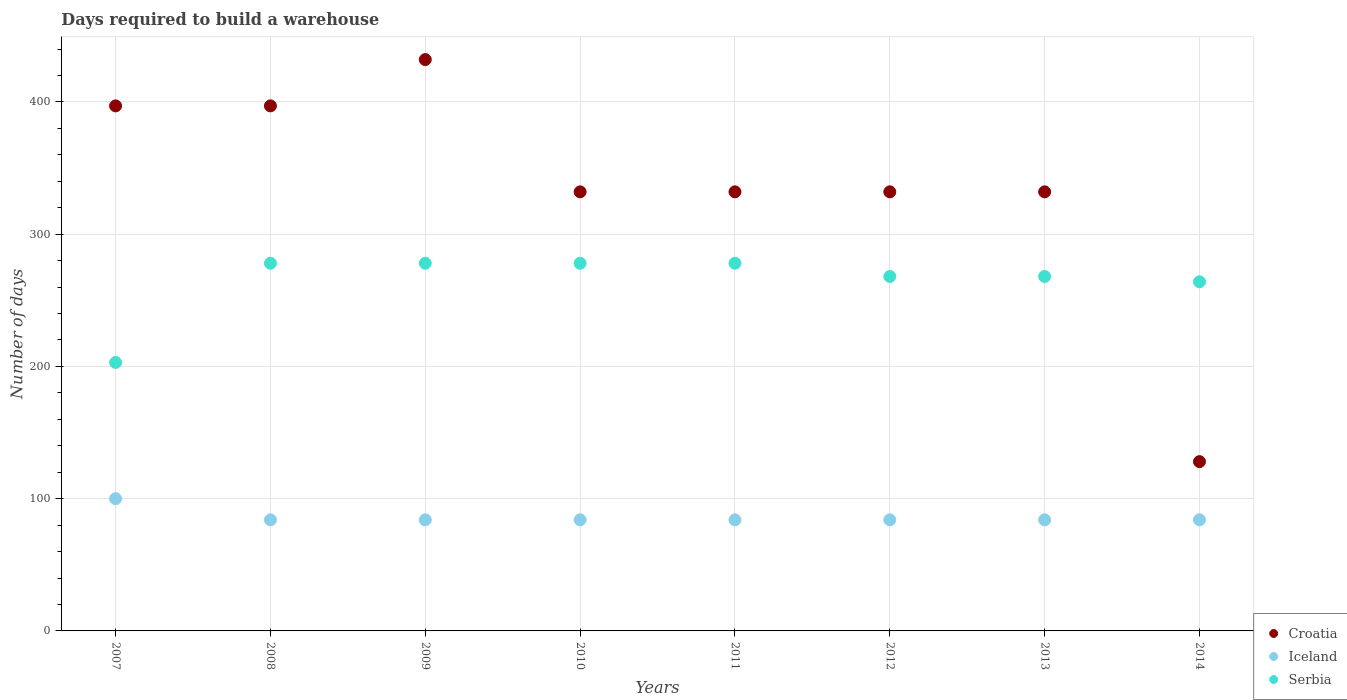What is the days required to build a warehouse in in Iceland in 2009?
Offer a very short reply. 84. Across all years, what is the maximum days required to build a warehouse in in Croatia?
Ensure brevity in your answer.  432. Across all years, what is the minimum days required to build a warehouse in in Croatia?
Ensure brevity in your answer.  128. In which year was the days required to build a warehouse in in Serbia maximum?
Your answer should be very brief. 2008. What is the total days required to build a warehouse in in Serbia in the graph?
Provide a short and direct response. 2115. What is the difference between the days required to build a warehouse in in Serbia in 2007 and that in 2014?
Keep it short and to the point. -61. What is the difference between the days required to build a warehouse in in Serbia in 2014 and the days required to build a warehouse in in Croatia in 2010?
Your answer should be compact. -68. What is the average days required to build a warehouse in in Iceland per year?
Ensure brevity in your answer.  86. In the year 2010, what is the difference between the days required to build a warehouse in in Croatia and days required to build a warehouse in in Iceland?
Provide a short and direct response. 248. In how many years, is the days required to build a warehouse in in Serbia greater than 420 days?
Provide a succinct answer. 0. What is the ratio of the days required to build a warehouse in in Croatia in 2011 to that in 2013?
Provide a succinct answer. 1. Is the days required to build a warehouse in in Croatia in 2011 less than that in 2012?
Your answer should be compact. No. What is the difference between the highest and the second highest days required to build a warehouse in in Croatia?
Your response must be concise. 35. What is the difference between the highest and the lowest days required to build a warehouse in in Iceland?
Give a very brief answer. 16. Is the sum of the days required to build a warehouse in in Serbia in 2007 and 2009 greater than the maximum days required to build a warehouse in in Croatia across all years?
Ensure brevity in your answer.  Yes. Does the days required to build a warehouse in in Iceland monotonically increase over the years?
Offer a very short reply. No. How many dotlines are there?
Offer a terse response. 3. How many years are there in the graph?
Provide a succinct answer. 8. Are the values on the major ticks of Y-axis written in scientific E-notation?
Offer a terse response. No. Does the graph contain grids?
Ensure brevity in your answer.  Yes. Where does the legend appear in the graph?
Make the answer very short. Bottom right. How are the legend labels stacked?
Make the answer very short. Vertical. What is the title of the graph?
Your answer should be compact. Days required to build a warehouse. What is the label or title of the X-axis?
Provide a short and direct response. Years. What is the label or title of the Y-axis?
Keep it short and to the point. Number of days. What is the Number of days in Croatia in 2007?
Offer a very short reply. 397. What is the Number of days of Iceland in 2007?
Your answer should be compact. 100. What is the Number of days in Serbia in 2007?
Keep it short and to the point. 203. What is the Number of days of Croatia in 2008?
Provide a succinct answer. 397. What is the Number of days in Iceland in 2008?
Offer a terse response. 84. What is the Number of days of Serbia in 2008?
Your answer should be compact. 278. What is the Number of days of Croatia in 2009?
Offer a terse response. 432. What is the Number of days in Serbia in 2009?
Offer a very short reply. 278. What is the Number of days in Croatia in 2010?
Offer a terse response. 332. What is the Number of days of Serbia in 2010?
Make the answer very short. 278. What is the Number of days in Croatia in 2011?
Provide a short and direct response. 332. What is the Number of days of Iceland in 2011?
Your answer should be very brief. 84. What is the Number of days in Serbia in 2011?
Your response must be concise. 278. What is the Number of days in Croatia in 2012?
Your answer should be compact. 332. What is the Number of days of Serbia in 2012?
Keep it short and to the point. 268. What is the Number of days of Croatia in 2013?
Offer a very short reply. 332. What is the Number of days of Serbia in 2013?
Give a very brief answer. 268. What is the Number of days of Croatia in 2014?
Ensure brevity in your answer.  128. What is the Number of days in Iceland in 2014?
Keep it short and to the point. 84. What is the Number of days in Serbia in 2014?
Your answer should be very brief. 264. Across all years, what is the maximum Number of days of Croatia?
Your answer should be compact. 432. Across all years, what is the maximum Number of days of Serbia?
Your answer should be very brief. 278. Across all years, what is the minimum Number of days of Croatia?
Your response must be concise. 128. Across all years, what is the minimum Number of days of Iceland?
Provide a succinct answer. 84. Across all years, what is the minimum Number of days of Serbia?
Make the answer very short. 203. What is the total Number of days in Croatia in the graph?
Your response must be concise. 2682. What is the total Number of days in Iceland in the graph?
Give a very brief answer. 688. What is the total Number of days of Serbia in the graph?
Offer a very short reply. 2115. What is the difference between the Number of days of Croatia in 2007 and that in 2008?
Your answer should be compact. 0. What is the difference between the Number of days in Iceland in 2007 and that in 2008?
Your answer should be compact. 16. What is the difference between the Number of days in Serbia in 2007 and that in 2008?
Ensure brevity in your answer.  -75. What is the difference between the Number of days in Croatia in 2007 and that in 2009?
Keep it short and to the point. -35. What is the difference between the Number of days of Serbia in 2007 and that in 2009?
Give a very brief answer. -75. What is the difference between the Number of days in Croatia in 2007 and that in 2010?
Your answer should be compact. 65. What is the difference between the Number of days of Serbia in 2007 and that in 2010?
Offer a very short reply. -75. What is the difference between the Number of days in Serbia in 2007 and that in 2011?
Your answer should be compact. -75. What is the difference between the Number of days of Croatia in 2007 and that in 2012?
Give a very brief answer. 65. What is the difference between the Number of days of Iceland in 2007 and that in 2012?
Your answer should be very brief. 16. What is the difference between the Number of days of Serbia in 2007 and that in 2012?
Make the answer very short. -65. What is the difference between the Number of days of Croatia in 2007 and that in 2013?
Keep it short and to the point. 65. What is the difference between the Number of days in Iceland in 2007 and that in 2013?
Your answer should be very brief. 16. What is the difference between the Number of days in Serbia in 2007 and that in 2013?
Make the answer very short. -65. What is the difference between the Number of days of Croatia in 2007 and that in 2014?
Offer a terse response. 269. What is the difference between the Number of days in Iceland in 2007 and that in 2014?
Ensure brevity in your answer.  16. What is the difference between the Number of days in Serbia in 2007 and that in 2014?
Your answer should be compact. -61. What is the difference between the Number of days of Croatia in 2008 and that in 2009?
Your response must be concise. -35. What is the difference between the Number of days of Iceland in 2008 and that in 2009?
Your answer should be compact. 0. What is the difference between the Number of days of Serbia in 2008 and that in 2009?
Ensure brevity in your answer.  0. What is the difference between the Number of days of Iceland in 2008 and that in 2010?
Keep it short and to the point. 0. What is the difference between the Number of days in Croatia in 2008 and that in 2011?
Your answer should be compact. 65. What is the difference between the Number of days in Iceland in 2008 and that in 2011?
Your answer should be very brief. 0. What is the difference between the Number of days in Croatia in 2008 and that in 2012?
Make the answer very short. 65. What is the difference between the Number of days of Iceland in 2008 and that in 2012?
Your answer should be very brief. 0. What is the difference between the Number of days of Serbia in 2008 and that in 2012?
Provide a short and direct response. 10. What is the difference between the Number of days in Croatia in 2008 and that in 2013?
Offer a very short reply. 65. What is the difference between the Number of days in Iceland in 2008 and that in 2013?
Your response must be concise. 0. What is the difference between the Number of days of Croatia in 2008 and that in 2014?
Your response must be concise. 269. What is the difference between the Number of days in Iceland in 2008 and that in 2014?
Ensure brevity in your answer.  0. What is the difference between the Number of days in Serbia in 2008 and that in 2014?
Your answer should be very brief. 14. What is the difference between the Number of days in Croatia in 2009 and that in 2010?
Provide a succinct answer. 100. What is the difference between the Number of days of Serbia in 2009 and that in 2010?
Offer a very short reply. 0. What is the difference between the Number of days in Serbia in 2009 and that in 2011?
Your answer should be compact. 0. What is the difference between the Number of days in Serbia in 2009 and that in 2012?
Your response must be concise. 10. What is the difference between the Number of days in Croatia in 2009 and that in 2013?
Provide a succinct answer. 100. What is the difference between the Number of days in Iceland in 2009 and that in 2013?
Make the answer very short. 0. What is the difference between the Number of days in Croatia in 2009 and that in 2014?
Make the answer very short. 304. What is the difference between the Number of days in Iceland in 2009 and that in 2014?
Offer a very short reply. 0. What is the difference between the Number of days in Croatia in 2010 and that in 2011?
Keep it short and to the point. 0. What is the difference between the Number of days in Iceland in 2010 and that in 2011?
Your response must be concise. 0. What is the difference between the Number of days in Serbia in 2010 and that in 2011?
Make the answer very short. 0. What is the difference between the Number of days of Croatia in 2010 and that in 2013?
Your answer should be compact. 0. What is the difference between the Number of days of Croatia in 2010 and that in 2014?
Give a very brief answer. 204. What is the difference between the Number of days of Croatia in 2011 and that in 2012?
Provide a short and direct response. 0. What is the difference between the Number of days of Iceland in 2011 and that in 2012?
Provide a succinct answer. 0. What is the difference between the Number of days in Serbia in 2011 and that in 2012?
Provide a succinct answer. 10. What is the difference between the Number of days of Croatia in 2011 and that in 2013?
Give a very brief answer. 0. What is the difference between the Number of days of Iceland in 2011 and that in 2013?
Offer a very short reply. 0. What is the difference between the Number of days of Croatia in 2011 and that in 2014?
Ensure brevity in your answer.  204. What is the difference between the Number of days of Croatia in 2012 and that in 2013?
Keep it short and to the point. 0. What is the difference between the Number of days of Iceland in 2012 and that in 2013?
Offer a very short reply. 0. What is the difference between the Number of days of Serbia in 2012 and that in 2013?
Your answer should be compact. 0. What is the difference between the Number of days of Croatia in 2012 and that in 2014?
Your answer should be very brief. 204. What is the difference between the Number of days in Iceland in 2012 and that in 2014?
Provide a short and direct response. 0. What is the difference between the Number of days in Serbia in 2012 and that in 2014?
Make the answer very short. 4. What is the difference between the Number of days of Croatia in 2013 and that in 2014?
Provide a short and direct response. 204. What is the difference between the Number of days in Iceland in 2013 and that in 2014?
Make the answer very short. 0. What is the difference between the Number of days in Serbia in 2013 and that in 2014?
Your response must be concise. 4. What is the difference between the Number of days in Croatia in 2007 and the Number of days in Iceland in 2008?
Make the answer very short. 313. What is the difference between the Number of days of Croatia in 2007 and the Number of days of Serbia in 2008?
Ensure brevity in your answer.  119. What is the difference between the Number of days of Iceland in 2007 and the Number of days of Serbia in 2008?
Offer a terse response. -178. What is the difference between the Number of days of Croatia in 2007 and the Number of days of Iceland in 2009?
Provide a short and direct response. 313. What is the difference between the Number of days in Croatia in 2007 and the Number of days in Serbia in 2009?
Your response must be concise. 119. What is the difference between the Number of days in Iceland in 2007 and the Number of days in Serbia in 2009?
Offer a terse response. -178. What is the difference between the Number of days in Croatia in 2007 and the Number of days in Iceland in 2010?
Your response must be concise. 313. What is the difference between the Number of days in Croatia in 2007 and the Number of days in Serbia in 2010?
Offer a terse response. 119. What is the difference between the Number of days of Iceland in 2007 and the Number of days of Serbia in 2010?
Your answer should be very brief. -178. What is the difference between the Number of days of Croatia in 2007 and the Number of days of Iceland in 2011?
Your response must be concise. 313. What is the difference between the Number of days in Croatia in 2007 and the Number of days in Serbia in 2011?
Provide a short and direct response. 119. What is the difference between the Number of days of Iceland in 2007 and the Number of days of Serbia in 2011?
Your answer should be compact. -178. What is the difference between the Number of days of Croatia in 2007 and the Number of days of Iceland in 2012?
Offer a terse response. 313. What is the difference between the Number of days of Croatia in 2007 and the Number of days of Serbia in 2012?
Offer a terse response. 129. What is the difference between the Number of days of Iceland in 2007 and the Number of days of Serbia in 2012?
Offer a terse response. -168. What is the difference between the Number of days in Croatia in 2007 and the Number of days in Iceland in 2013?
Give a very brief answer. 313. What is the difference between the Number of days of Croatia in 2007 and the Number of days of Serbia in 2013?
Offer a very short reply. 129. What is the difference between the Number of days of Iceland in 2007 and the Number of days of Serbia in 2013?
Make the answer very short. -168. What is the difference between the Number of days of Croatia in 2007 and the Number of days of Iceland in 2014?
Your response must be concise. 313. What is the difference between the Number of days in Croatia in 2007 and the Number of days in Serbia in 2014?
Your answer should be very brief. 133. What is the difference between the Number of days in Iceland in 2007 and the Number of days in Serbia in 2014?
Your answer should be compact. -164. What is the difference between the Number of days in Croatia in 2008 and the Number of days in Iceland in 2009?
Your answer should be very brief. 313. What is the difference between the Number of days of Croatia in 2008 and the Number of days of Serbia in 2009?
Keep it short and to the point. 119. What is the difference between the Number of days of Iceland in 2008 and the Number of days of Serbia in 2009?
Your answer should be compact. -194. What is the difference between the Number of days in Croatia in 2008 and the Number of days in Iceland in 2010?
Provide a succinct answer. 313. What is the difference between the Number of days of Croatia in 2008 and the Number of days of Serbia in 2010?
Ensure brevity in your answer.  119. What is the difference between the Number of days in Iceland in 2008 and the Number of days in Serbia in 2010?
Offer a very short reply. -194. What is the difference between the Number of days in Croatia in 2008 and the Number of days in Iceland in 2011?
Make the answer very short. 313. What is the difference between the Number of days in Croatia in 2008 and the Number of days in Serbia in 2011?
Give a very brief answer. 119. What is the difference between the Number of days of Iceland in 2008 and the Number of days of Serbia in 2011?
Your answer should be very brief. -194. What is the difference between the Number of days of Croatia in 2008 and the Number of days of Iceland in 2012?
Keep it short and to the point. 313. What is the difference between the Number of days in Croatia in 2008 and the Number of days in Serbia in 2012?
Provide a succinct answer. 129. What is the difference between the Number of days in Iceland in 2008 and the Number of days in Serbia in 2012?
Keep it short and to the point. -184. What is the difference between the Number of days of Croatia in 2008 and the Number of days of Iceland in 2013?
Your answer should be compact. 313. What is the difference between the Number of days in Croatia in 2008 and the Number of days in Serbia in 2013?
Your response must be concise. 129. What is the difference between the Number of days of Iceland in 2008 and the Number of days of Serbia in 2013?
Your answer should be very brief. -184. What is the difference between the Number of days of Croatia in 2008 and the Number of days of Iceland in 2014?
Your response must be concise. 313. What is the difference between the Number of days in Croatia in 2008 and the Number of days in Serbia in 2014?
Your answer should be very brief. 133. What is the difference between the Number of days of Iceland in 2008 and the Number of days of Serbia in 2014?
Offer a very short reply. -180. What is the difference between the Number of days of Croatia in 2009 and the Number of days of Iceland in 2010?
Keep it short and to the point. 348. What is the difference between the Number of days in Croatia in 2009 and the Number of days in Serbia in 2010?
Your answer should be very brief. 154. What is the difference between the Number of days of Iceland in 2009 and the Number of days of Serbia in 2010?
Offer a very short reply. -194. What is the difference between the Number of days in Croatia in 2009 and the Number of days in Iceland in 2011?
Provide a short and direct response. 348. What is the difference between the Number of days in Croatia in 2009 and the Number of days in Serbia in 2011?
Provide a short and direct response. 154. What is the difference between the Number of days in Iceland in 2009 and the Number of days in Serbia in 2011?
Offer a very short reply. -194. What is the difference between the Number of days in Croatia in 2009 and the Number of days in Iceland in 2012?
Offer a terse response. 348. What is the difference between the Number of days in Croatia in 2009 and the Number of days in Serbia in 2012?
Give a very brief answer. 164. What is the difference between the Number of days in Iceland in 2009 and the Number of days in Serbia in 2012?
Keep it short and to the point. -184. What is the difference between the Number of days in Croatia in 2009 and the Number of days in Iceland in 2013?
Your answer should be compact. 348. What is the difference between the Number of days in Croatia in 2009 and the Number of days in Serbia in 2013?
Make the answer very short. 164. What is the difference between the Number of days of Iceland in 2009 and the Number of days of Serbia in 2013?
Offer a very short reply. -184. What is the difference between the Number of days in Croatia in 2009 and the Number of days in Iceland in 2014?
Ensure brevity in your answer.  348. What is the difference between the Number of days in Croatia in 2009 and the Number of days in Serbia in 2014?
Make the answer very short. 168. What is the difference between the Number of days of Iceland in 2009 and the Number of days of Serbia in 2014?
Your answer should be very brief. -180. What is the difference between the Number of days in Croatia in 2010 and the Number of days in Iceland in 2011?
Your answer should be very brief. 248. What is the difference between the Number of days of Croatia in 2010 and the Number of days of Serbia in 2011?
Your answer should be very brief. 54. What is the difference between the Number of days of Iceland in 2010 and the Number of days of Serbia in 2011?
Provide a short and direct response. -194. What is the difference between the Number of days of Croatia in 2010 and the Number of days of Iceland in 2012?
Ensure brevity in your answer.  248. What is the difference between the Number of days in Croatia in 2010 and the Number of days in Serbia in 2012?
Offer a terse response. 64. What is the difference between the Number of days of Iceland in 2010 and the Number of days of Serbia in 2012?
Provide a succinct answer. -184. What is the difference between the Number of days of Croatia in 2010 and the Number of days of Iceland in 2013?
Ensure brevity in your answer.  248. What is the difference between the Number of days of Iceland in 2010 and the Number of days of Serbia in 2013?
Offer a terse response. -184. What is the difference between the Number of days in Croatia in 2010 and the Number of days in Iceland in 2014?
Provide a succinct answer. 248. What is the difference between the Number of days in Croatia in 2010 and the Number of days in Serbia in 2014?
Your answer should be compact. 68. What is the difference between the Number of days in Iceland in 2010 and the Number of days in Serbia in 2014?
Keep it short and to the point. -180. What is the difference between the Number of days of Croatia in 2011 and the Number of days of Iceland in 2012?
Provide a short and direct response. 248. What is the difference between the Number of days in Croatia in 2011 and the Number of days in Serbia in 2012?
Provide a succinct answer. 64. What is the difference between the Number of days in Iceland in 2011 and the Number of days in Serbia in 2012?
Your response must be concise. -184. What is the difference between the Number of days in Croatia in 2011 and the Number of days in Iceland in 2013?
Offer a very short reply. 248. What is the difference between the Number of days in Croatia in 2011 and the Number of days in Serbia in 2013?
Offer a terse response. 64. What is the difference between the Number of days of Iceland in 2011 and the Number of days of Serbia in 2013?
Provide a succinct answer. -184. What is the difference between the Number of days in Croatia in 2011 and the Number of days in Iceland in 2014?
Provide a short and direct response. 248. What is the difference between the Number of days in Croatia in 2011 and the Number of days in Serbia in 2014?
Your answer should be compact. 68. What is the difference between the Number of days in Iceland in 2011 and the Number of days in Serbia in 2014?
Your response must be concise. -180. What is the difference between the Number of days of Croatia in 2012 and the Number of days of Iceland in 2013?
Your response must be concise. 248. What is the difference between the Number of days in Croatia in 2012 and the Number of days in Serbia in 2013?
Keep it short and to the point. 64. What is the difference between the Number of days of Iceland in 2012 and the Number of days of Serbia in 2013?
Make the answer very short. -184. What is the difference between the Number of days in Croatia in 2012 and the Number of days in Iceland in 2014?
Your response must be concise. 248. What is the difference between the Number of days in Iceland in 2012 and the Number of days in Serbia in 2014?
Your response must be concise. -180. What is the difference between the Number of days of Croatia in 2013 and the Number of days of Iceland in 2014?
Give a very brief answer. 248. What is the difference between the Number of days in Croatia in 2013 and the Number of days in Serbia in 2014?
Provide a short and direct response. 68. What is the difference between the Number of days of Iceland in 2013 and the Number of days of Serbia in 2014?
Your answer should be compact. -180. What is the average Number of days of Croatia per year?
Your answer should be very brief. 335.25. What is the average Number of days in Iceland per year?
Offer a terse response. 86. What is the average Number of days in Serbia per year?
Your answer should be very brief. 264.38. In the year 2007, what is the difference between the Number of days in Croatia and Number of days in Iceland?
Your answer should be very brief. 297. In the year 2007, what is the difference between the Number of days of Croatia and Number of days of Serbia?
Ensure brevity in your answer.  194. In the year 2007, what is the difference between the Number of days of Iceland and Number of days of Serbia?
Give a very brief answer. -103. In the year 2008, what is the difference between the Number of days of Croatia and Number of days of Iceland?
Your answer should be compact. 313. In the year 2008, what is the difference between the Number of days of Croatia and Number of days of Serbia?
Provide a short and direct response. 119. In the year 2008, what is the difference between the Number of days in Iceland and Number of days in Serbia?
Provide a short and direct response. -194. In the year 2009, what is the difference between the Number of days in Croatia and Number of days in Iceland?
Make the answer very short. 348. In the year 2009, what is the difference between the Number of days of Croatia and Number of days of Serbia?
Your answer should be compact. 154. In the year 2009, what is the difference between the Number of days in Iceland and Number of days in Serbia?
Offer a very short reply. -194. In the year 2010, what is the difference between the Number of days in Croatia and Number of days in Iceland?
Ensure brevity in your answer.  248. In the year 2010, what is the difference between the Number of days of Croatia and Number of days of Serbia?
Give a very brief answer. 54. In the year 2010, what is the difference between the Number of days of Iceland and Number of days of Serbia?
Offer a very short reply. -194. In the year 2011, what is the difference between the Number of days in Croatia and Number of days in Iceland?
Your response must be concise. 248. In the year 2011, what is the difference between the Number of days in Iceland and Number of days in Serbia?
Keep it short and to the point. -194. In the year 2012, what is the difference between the Number of days in Croatia and Number of days in Iceland?
Give a very brief answer. 248. In the year 2012, what is the difference between the Number of days of Croatia and Number of days of Serbia?
Offer a very short reply. 64. In the year 2012, what is the difference between the Number of days in Iceland and Number of days in Serbia?
Make the answer very short. -184. In the year 2013, what is the difference between the Number of days of Croatia and Number of days of Iceland?
Offer a terse response. 248. In the year 2013, what is the difference between the Number of days of Croatia and Number of days of Serbia?
Your answer should be very brief. 64. In the year 2013, what is the difference between the Number of days of Iceland and Number of days of Serbia?
Your answer should be very brief. -184. In the year 2014, what is the difference between the Number of days in Croatia and Number of days in Serbia?
Provide a short and direct response. -136. In the year 2014, what is the difference between the Number of days of Iceland and Number of days of Serbia?
Ensure brevity in your answer.  -180. What is the ratio of the Number of days of Croatia in 2007 to that in 2008?
Keep it short and to the point. 1. What is the ratio of the Number of days of Iceland in 2007 to that in 2008?
Give a very brief answer. 1.19. What is the ratio of the Number of days of Serbia in 2007 to that in 2008?
Provide a succinct answer. 0.73. What is the ratio of the Number of days of Croatia in 2007 to that in 2009?
Your answer should be very brief. 0.92. What is the ratio of the Number of days of Iceland in 2007 to that in 2009?
Ensure brevity in your answer.  1.19. What is the ratio of the Number of days of Serbia in 2007 to that in 2009?
Give a very brief answer. 0.73. What is the ratio of the Number of days of Croatia in 2007 to that in 2010?
Give a very brief answer. 1.2. What is the ratio of the Number of days in Iceland in 2007 to that in 2010?
Offer a very short reply. 1.19. What is the ratio of the Number of days in Serbia in 2007 to that in 2010?
Keep it short and to the point. 0.73. What is the ratio of the Number of days in Croatia in 2007 to that in 2011?
Your answer should be compact. 1.2. What is the ratio of the Number of days in Iceland in 2007 to that in 2011?
Your response must be concise. 1.19. What is the ratio of the Number of days of Serbia in 2007 to that in 2011?
Make the answer very short. 0.73. What is the ratio of the Number of days of Croatia in 2007 to that in 2012?
Offer a very short reply. 1.2. What is the ratio of the Number of days in Iceland in 2007 to that in 2012?
Offer a very short reply. 1.19. What is the ratio of the Number of days of Serbia in 2007 to that in 2012?
Ensure brevity in your answer.  0.76. What is the ratio of the Number of days in Croatia in 2007 to that in 2013?
Offer a very short reply. 1.2. What is the ratio of the Number of days of Iceland in 2007 to that in 2013?
Offer a terse response. 1.19. What is the ratio of the Number of days in Serbia in 2007 to that in 2013?
Offer a terse response. 0.76. What is the ratio of the Number of days of Croatia in 2007 to that in 2014?
Make the answer very short. 3.1. What is the ratio of the Number of days in Iceland in 2007 to that in 2014?
Offer a very short reply. 1.19. What is the ratio of the Number of days in Serbia in 2007 to that in 2014?
Offer a very short reply. 0.77. What is the ratio of the Number of days of Croatia in 2008 to that in 2009?
Give a very brief answer. 0.92. What is the ratio of the Number of days in Serbia in 2008 to that in 2009?
Offer a terse response. 1. What is the ratio of the Number of days in Croatia in 2008 to that in 2010?
Your answer should be very brief. 1.2. What is the ratio of the Number of days in Iceland in 2008 to that in 2010?
Provide a short and direct response. 1. What is the ratio of the Number of days of Serbia in 2008 to that in 2010?
Provide a succinct answer. 1. What is the ratio of the Number of days in Croatia in 2008 to that in 2011?
Give a very brief answer. 1.2. What is the ratio of the Number of days in Iceland in 2008 to that in 2011?
Offer a terse response. 1. What is the ratio of the Number of days of Croatia in 2008 to that in 2012?
Provide a succinct answer. 1.2. What is the ratio of the Number of days in Iceland in 2008 to that in 2012?
Make the answer very short. 1. What is the ratio of the Number of days of Serbia in 2008 to that in 2012?
Ensure brevity in your answer.  1.04. What is the ratio of the Number of days of Croatia in 2008 to that in 2013?
Your answer should be very brief. 1.2. What is the ratio of the Number of days in Serbia in 2008 to that in 2013?
Keep it short and to the point. 1.04. What is the ratio of the Number of days of Croatia in 2008 to that in 2014?
Your answer should be very brief. 3.1. What is the ratio of the Number of days of Serbia in 2008 to that in 2014?
Your answer should be very brief. 1.05. What is the ratio of the Number of days of Croatia in 2009 to that in 2010?
Your answer should be compact. 1.3. What is the ratio of the Number of days of Iceland in 2009 to that in 2010?
Your response must be concise. 1. What is the ratio of the Number of days of Serbia in 2009 to that in 2010?
Provide a short and direct response. 1. What is the ratio of the Number of days of Croatia in 2009 to that in 2011?
Your response must be concise. 1.3. What is the ratio of the Number of days of Iceland in 2009 to that in 2011?
Keep it short and to the point. 1. What is the ratio of the Number of days of Serbia in 2009 to that in 2011?
Provide a short and direct response. 1. What is the ratio of the Number of days of Croatia in 2009 to that in 2012?
Your answer should be compact. 1.3. What is the ratio of the Number of days of Serbia in 2009 to that in 2012?
Offer a terse response. 1.04. What is the ratio of the Number of days in Croatia in 2009 to that in 2013?
Offer a terse response. 1.3. What is the ratio of the Number of days in Serbia in 2009 to that in 2013?
Provide a succinct answer. 1.04. What is the ratio of the Number of days of Croatia in 2009 to that in 2014?
Provide a succinct answer. 3.38. What is the ratio of the Number of days in Iceland in 2009 to that in 2014?
Your answer should be very brief. 1. What is the ratio of the Number of days in Serbia in 2009 to that in 2014?
Make the answer very short. 1.05. What is the ratio of the Number of days in Croatia in 2010 to that in 2011?
Keep it short and to the point. 1. What is the ratio of the Number of days in Iceland in 2010 to that in 2011?
Your response must be concise. 1. What is the ratio of the Number of days of Croatia in 2010 to that in 2012?
Provide a short and direct response. 1. What is the ratio of the Number of days in Iceland in 2010 to that in 2012?
Keep it short and to the point. 1. What is the ratio of the Number of days in Serbia in 2010 to that in 2012?
Keep it short and to the point. 1.04. What is the ratio of the Number of days of Iceland in 2010 to that in 2013?
Ensure brevity in your answer.  1. What is the ratio of the Number of days of Serbia in 2010 to that in 2013?
Keep it short and to the point. 1.04. What is the ratio of the Number of days of Croatia in 2010 to that in 2014?
Provide a succinct answer. 2.59. What is the ratio of the Number of days of Serbia in 2010 to that in 2014?
Make the answer very short. 1.05. What is the ratio of the Number of days of Croatia in 2011 to that in 2012?
Make the answer very short. 1. What is the ratio of the Number of days of Serbia in 2011 to that in 2012?
Make the answer very short. 1.04. What is the ratio of the Number of days in Iceland in 2011 to that in 2013?
Keep it short and to the point. 1. What is the ratio of the Number of days in Serbia in 2011 to that in 2013?
Keep it short and to the point. 1.04. What is the ratio of the Number of days in Croatia in 2011 to that in 2014?
Your answer should be very brief. 2.59. What is the ratio of the Number of days in Iceland in 2011 to that in 2014?
Make the answer very short. 1. What is the ratio of the Number of days of Serbia in 2011 to that in 2014?
Provide a succinct answer. 1.05. What is the ratio of the Number of days in Croatia in 2012 to that in 2013?
Keep it short and to the point. 1. What is the ratio of the Number of days of Iceland in 2012 to that in 2013?
Keep it short and to the point. 1. What is the ratio of the Number of days of Serbia in 2012 to that in 2013?
Keep it short and to the point. 1. What is the ratio of the Number of days of Croatia in 2012 to that in 2014?
Give a very brief answer. 2.59. What is the ratio of the Number of days in Iceland in 2012 to that in 2014?
Make the answer very short. 1. What is the ratio of the Number of days in Serbia in 2012 to that in 2014?
Offer a terse response. 1.02. What is the ratio of the Number of days of Croatia in 2013 to that in 2014?
Your response must be concise. 2.59. What is the ratio of the Number of days of Iceland in 2013 to that in 2014?
Provide a short and direct response. 1. What is the ratio of the Number of days of Serbia in 2013 to that in 2014?
Your answer should be compact. 1.02. What is the difference between the highest and the second highest Number of days in Croatia?
Make the answer very short. 35. What is the difference between the highest and the second highest Number of days in Serbia?
Make the answer very short. 0. What is the difference between the highest and the lowest Number of days in Croatia?
Offer a terse response. 304. What is the difference between the highest and the lowest Number of days of Serbia?
Provide a short and direct response. 75. 